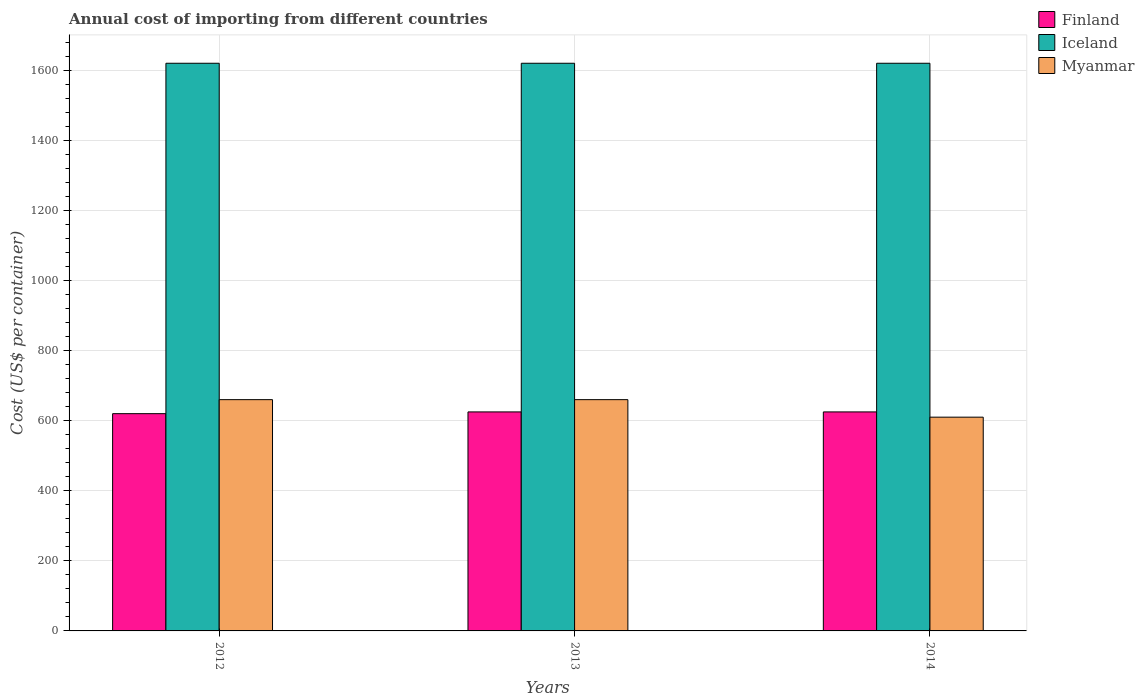How many groups of bars are there?
Ensure brevity in your answer.  3. Are the number of bars per tick equal to the number of legend labels?
Offer a terse response. Yes. How many bars are there on the 2nd tick from the left?
Your answer should be very brief. 3. What is the label of the 2nd group of bars from the left?
Ensure brevity in your answer.  2013. What is the total annual cost of importing in Iceland in 2012?
Keep it short and to the point. 1620. Across all years, what is the maximum total annual cost of importing in Finland?
Offer a terse response. 625. Across all years, what is the minimum total annual cost of importing in Myanmar?
Offer a terse response. 610. What is the total total annual cost of importing in Myanmar in the graph?
Offer a very short reply. 1930. What is the difference between the total annual cost of importing in Finland in 2012 and that in 2013?
Give a very brief answer. -5. What is the average total annual cost of importing in Finland per year?
Provide a succinct answer. 623.33. In the year 2012, what is the difference between the total annual cost of importing in Finland and total annual cost of importing in Myanmar?
Provide a succinct answer. -40. What is the ratio of the total annual cost of importing in Myanmar in 2012 to that in 2014?
Provide a short and direct response. 1.08. Is the total annual cost of importing in Finland in 2013 less than that in 2014?
Make the answer very short. No. Is the sum of the total annual cost of importing in Myanmar in 2012 and 2013 greater than the maximum total annual cost of importing in Finland across all years?
Make the answer very short. Yes. Is it the case that in every year, the sum of the total annual cost of importing in Myanmar and total annual cost of importing in Iceland is greater than the total annual cost of importing in Finland?
Give a very brief answer. Yes. Are all the bars in the graph horizontal?
Ensure brevity in your answer.  No. What is the difference between two consecutive major ticks on the Y-axis?
Ensure brevity in your answer.  200. Does the graph contain any zero values?
Provide a succinct answer. No. Does the graph contain grids?
Make the answer very short. Yes. How many legend labels are there?
Give a very brief answer. 3. How are the legend labels stacked?
Make the answer very short. Vertical. What is the title of the graph?
Make the answer very short. Annual cost of importing from different countries. Does "Burkina Faso" appear as one of the legend labels in the graph?
Ensure brevity in your answer.  No. What is the label or title of the Y-axis?
Your response must be concise. Cost (US$ per container). What is the Cost (US$ per container) of Finland in 2012?
Offer a terse response. 620. What is the Cost (US$ per container) of Iceland in 2012?
Provide a short and direct response. 1620. What is the Cost (US$ per container) in Myanmar in 2012?
Your response must be concise. 660. What is the Cost (US$ per container) of Finland in 2013?
Your answer should be compact. 625. What is the Cost (US$ per container) in Iceland in 2013?
Make the answer very short. 1620. What is the Cost (US$ per container) of Myanmar in 2013?
Keep it short and to the point. 660. What is the Cost (US$ per container) of Finland in 2014?
Offer a terse response. 625. What is the Cost (US$ per container) in Iceland in 2014?
Make the answer very short. 1620. What is the Cost (US$ per container) in Myanmar in 2014?
Offer a terse response. 610. Across all years, what is the maximum Cost (US$ per container) of Finland?
Your response must be concise. 625. Across all years, what is the maximum Cost (US$ per container) of Iceland?
Provide a succinct answer. 1620. Across all years, what is the maximum Cost (US$ per container) in Myanmar?
Make the answer very short. 660. Across all years, what is the minimum Cost (US$ per container) in Finland?
Provide a succinct answer. 620. Across all years, what is the minimum Cost (US$ per container) of Iceland?
Offer a terse response. 1620. Across all years, what is the minimum Cost (US$ per container) in Myanmar?
Offer a very short reply. 610. What is the total Cost (US$ per container) in Finland in the graph?
Keep it short and to the point. 1870. What is the total Cost (US$ per container) of Iceland in the graph?
Give a very brief answer. 4860. What is the total Cost (US$ per container) of Myanmar in the graph?
Your response must be concise. 1930. What is the difference between the Cost (US$ per container) of Finland in 2012 and that in 2013?
Give a very brief answer. -5. What is the difference between the Cost (US$ per container) of Finland in 2012 and that in 2014?
Keep it short and to the point. -5. What is the difference between the Cost (US$ per container) of Iceland in 2012 and that in 2014?
Ensure brevity in your answer.  0. What is the difference between the Cost (US$ per container) of Myanmar in 2012 and that in 2014?
Provide a succinct answer. 50. What is the difference between the Cost (US$ per container) of Iceland in 2013 and that in 2014?
Ensure brevity in your answer.  0. What is the difference between the Cost (US$ per container) in Finland in 2012 and the Cost (US$ per container) in Iceland in 2013?
Offer a terse response. -1000. What is the difference between the Cost (US$ per container) in Iceland in 2012 and the Cost (US$ per container) in Myanmar in 2013?
Keep it short and to the point. 960. What is the difference between the Cost (US$ per container) in Finland in 2012 and the Cost (US$ per container) in Iceland in 2014?
Provide a short and direct response. -1000. What is the difference between the Cost (US$ per container) in Finland in 2012 and the Cost (US$ per container) in Myanmar in 2014?
Your answer should be very brief. 10. What is the difference between the Cost (US$ per container) in Iceland in 2012 and the Cost (US$ per container) in Myanmar in 2014?
Keep it short and to the point. 1010. What is the difference between the Cost (US$ per container) in Finland in 2013 and the Cost (US$ per container) in Iceland in 2014?
Your response must be concise. -995. What is the difference between the Cost (US$ per container) of Iceland in 2013 and the Cost (US$ per container) of Myanmar in 2014?
Provide a succinct answer. 1010. What is the average Cost (US$ per container) in Finland per year?
Ensure brevity in your answer.  623.33. What is the average Cost (US$ per container) of Iceland per year?
Your answer should be compact. 1620. What is the average Cost (US$ per container) in Myanmar per year?
Provide a succinct answer. 643.33. In the year 2012, what is the difference between the Cost (US$ per container) in Finland and Cost (US$ per container) in Iceland?
Ensure brevity in your answer.  -1000. In the year 2012, what is the difference between the Cost (US$ per container) in Iceland and Cost (US$ per container) in Myanmar?
Provide a short and direct response. 960. In the year 2013, what is the difference between the Cost (US$ per container) of Finland and Cost (US$ per container) of Iceland?
Provide a succinct answer. -995. In the year 2013, what is the difference between the Cost (US$ per container) in Finland and Cost (US$ per container) in Myanmar?
Offer a terse response. -35. In the year 2013, what is the difference between the Cost (US$ per container) in Iceland and Cost (US$ per container) in Myanmar?
Provide a succinct answer. 960. In the year 2014, what is the difference between the Cost (US$ per container) in Finland and Cost (US$ per container) in Iceland?
Provide a succinct answer. -995. In the year 2014, what is the difference between the Cost (US$ per container) of Finland and Cost (US$ per container) of Myanmar?
Your answer should be compact. 15. In the year 2014, what is the difference between the Cost (US$ per container) in Iceland and Cost (US$ per container) in Myanmar?
Offer a terse response. 1010. What is the ratio of the Cost (US$ per container) in Finland in 2012 to that in 2013?
Offer a very short reply. 0.99. What is the ratio of the Cost (US$ per container) of Myanmar in 2012 to that in 2013?
Offer a terse response. 1. What is the ratio of the Cost (US$ per container) in Iceland in 2012 to that in 2014?
Offer a very short reply. 1. What is the ratio of the Cost (US$ per container) in Myanmar in 2012 to that in 2014?
Keep it short and to the point. 1.08. What is the ratio of the Cost (US$ per container) of Iceland in 2013 to that in 2014?
Your answer should be very brief. 1. What is the ratio of the Cost (US$ per container) in Myanmar in 2013 to that in 2014?
Offer a very short reply. 1.08. What is the difference between the highest and the lowest Cost (US$ per container) in Iceland?
Your answer should be very brief. 0. 